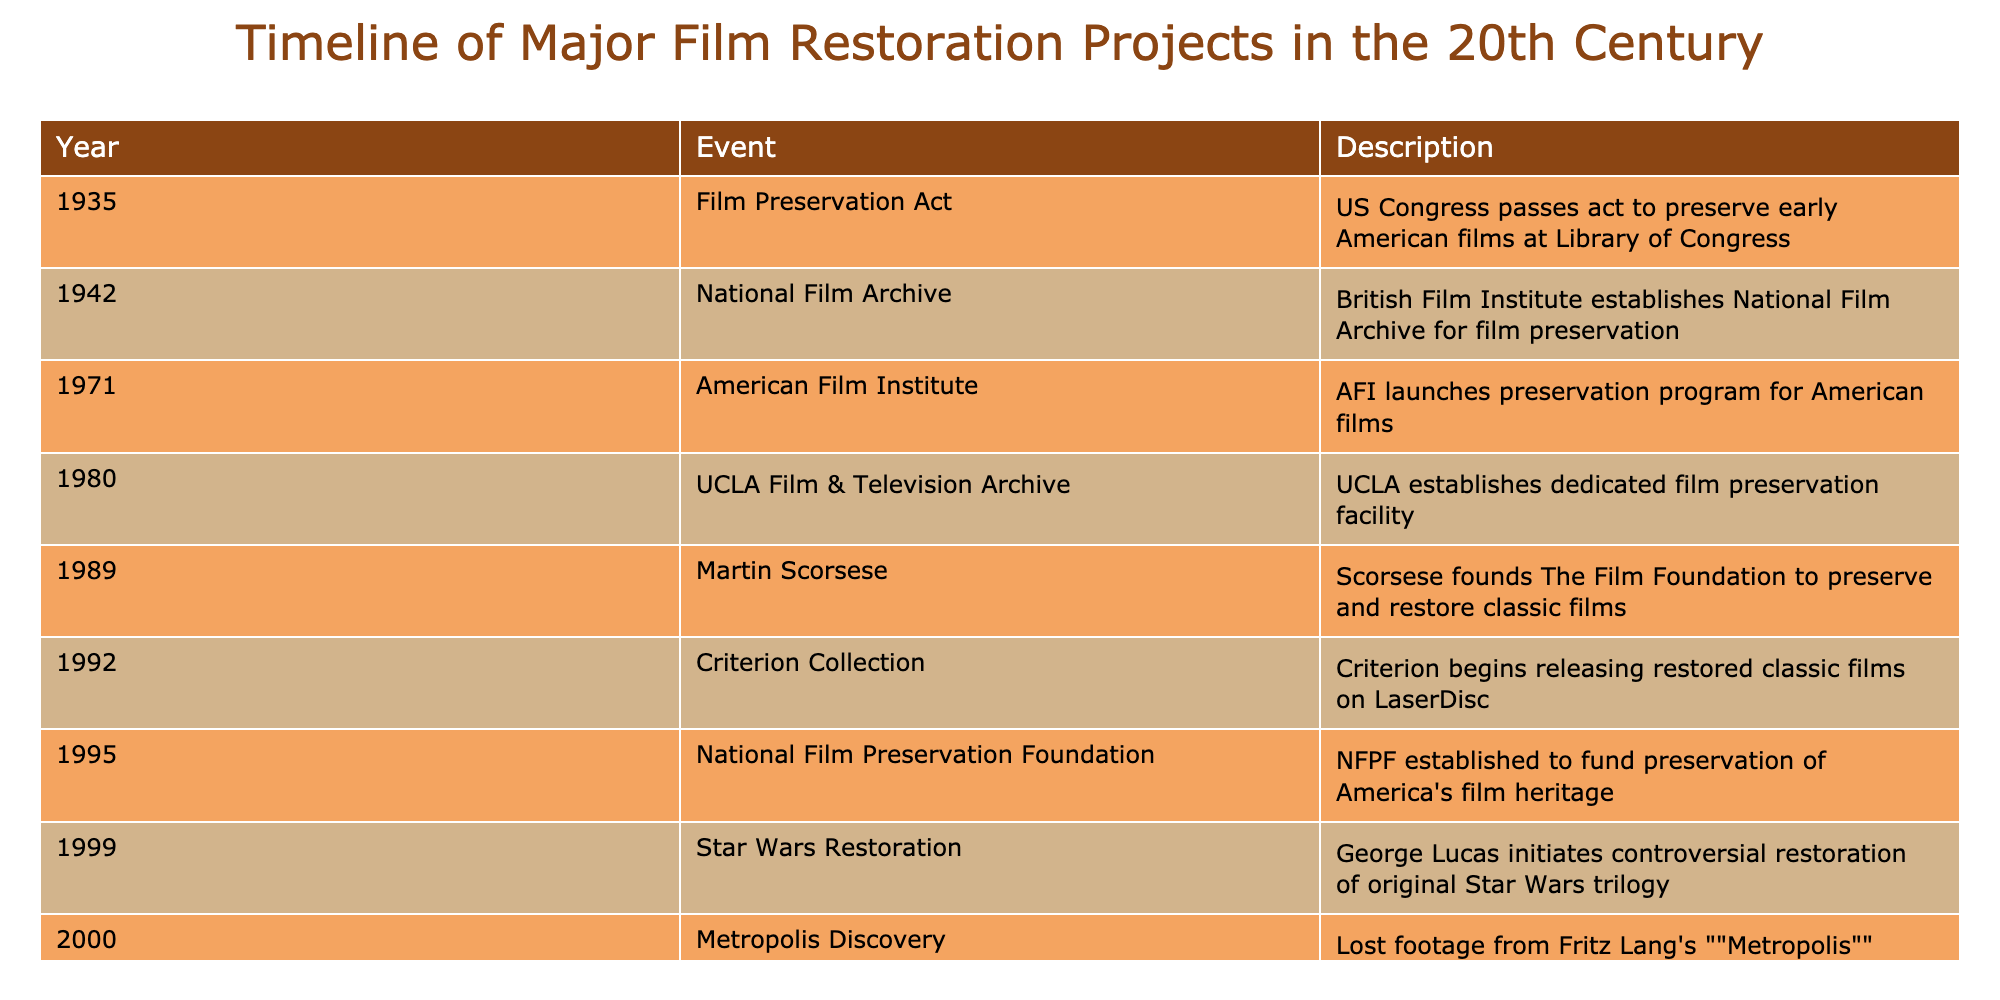What year was the Film Preservation Act passed? The table states that the Film Preservation Act was passed in 1935.
Answer: 1935 Which event marked the establishment of the National Film Archive? According to the table, the British Film Institute established the National Film Archive in 1942.
Answer: 1942 How many film preservation events occurred before 1970? By reviewing the years listed, there are three events before 1970: the Film Preservation Act (1935), the creation of the National Film Archive (1942), and the establishment of the American Film Institute's preservation program (1971). The total count of events before 1970 is 3.
Answer: 3 Did Martin Scorsese found The Film Foundation before or after 1985? The table shows that Martin Scorsese founded The Film Foundation in 1989, which is after 1985.
Answer: After What significant discovery related to Metropolis occurred in 2000? In 2000, the lost footage from Fritz Lang's Metropolis, originally made in 1927, was discovered in Argentina. This event is specifically highlighted in the table.
Answer: Lost footage discovery in Argentina What is the difference in years between the establishment of the American Film Institute’s preservation program and the National Film Archive? The American Film Institute’s preservation program was launched in 1971 and the National Film Archive was established in 1942. The difference in years is 1971 - 1942 = 29 years.
Answer: 29 years Were any preservation projects initiated in the 1990s? Yes, according to the table, both the establishment of the National Film Preservation Foundation in 1995 and the Criterion Collection's releases of restored classic films in 1992 were significant events in film preservation during the 1990s.
Answer: Yes What was the last major film restoration project listed in the table? The last project listed is the discovery of lost footage from Fritz Lang's Metropolis in 2000, which is the most recent event in the timeline.
Answer: Discovery of Metropolis footage in 2000 Which years saw the establishment of significant film preservation organizations? The years 1942 (National Film Archive), 1971 (American Film Institute), and 1995 (National Film Preservation Foundation) saw the establishment of significant film preservation organizations according to the timeline.
Answer: 1942, 1971, 1995 